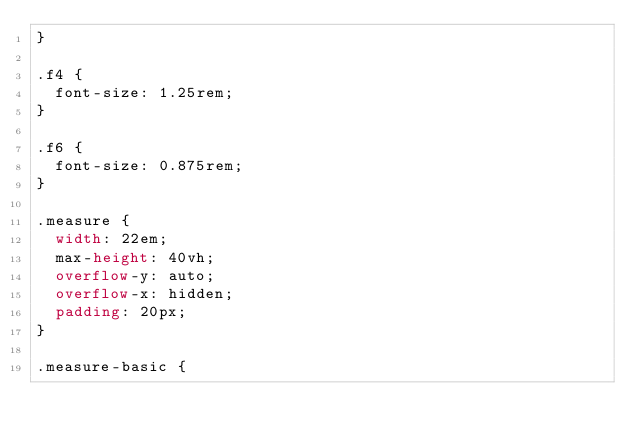Convert code to text. <code><loc_0><loc_0><loc_500><loc_500><_CSS_>}

.f4 {
  font-size: 1.25rem;
}

.f6 {
  font-size: 0.875rem;
}

.measure {
  width: 22em;
  max-height: 40vh;
  overflow-y: auto;
  overflow-x: hidden;
  padding: 20px;
}

.measure-basic {</code> 